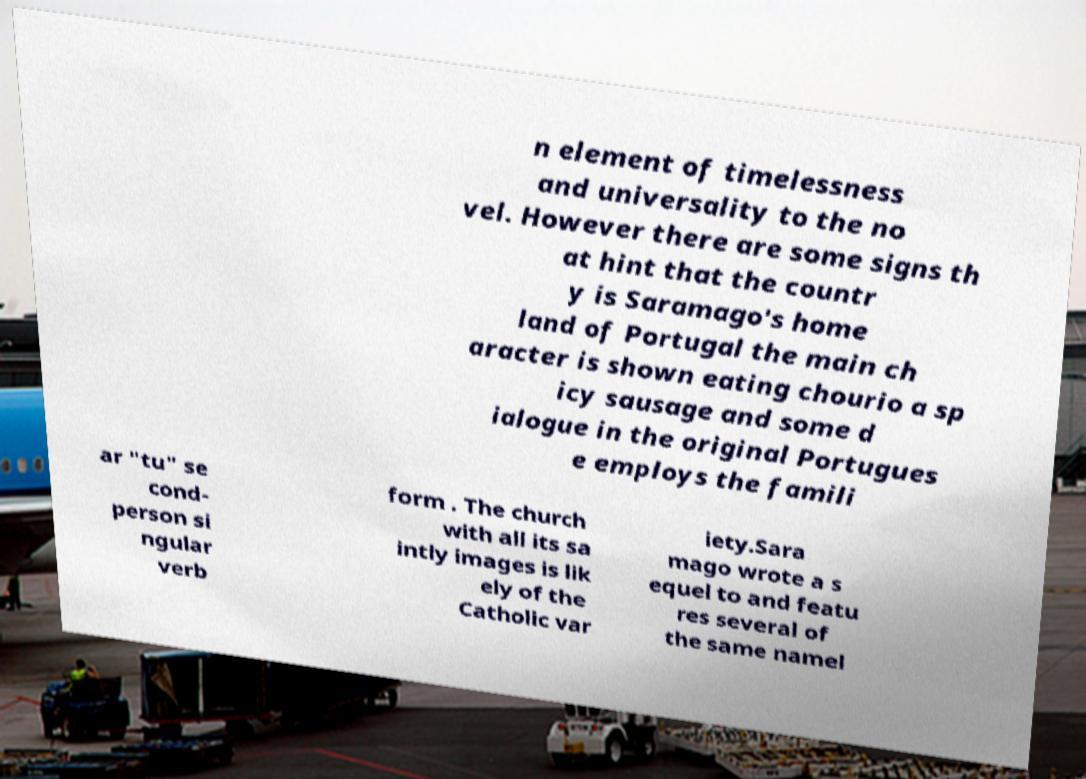Can you read and provide the text displayed in the image?This photo seems to have some interesting text. Can you extract and type it out for me? n element of timelessness and universality to the no vel. However there are some signs th at hint that the countr y is Saramago's home land of Portugal the main ch aracter is shown eating chourio a sp icy sausage and some d ialogue in the original Portugues e employs the famili ar "tu" se cond- person si ngular verb form . The church with all its sa intly images is lik ely of the Catholic var iety.Sara mago wrote a s equel to and featu res several of the same namel 